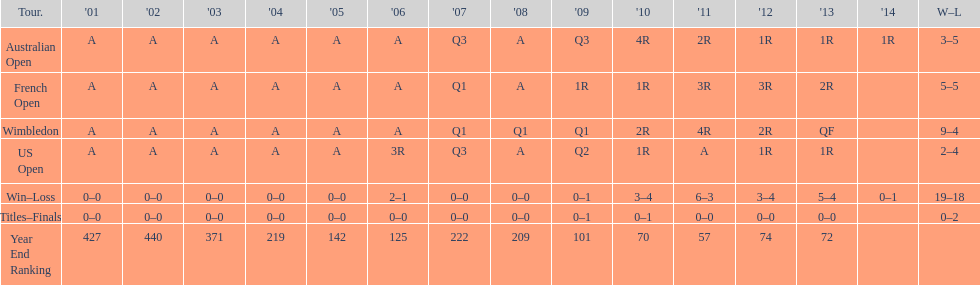Which tournament has the largest total win record? Wimbledon. 